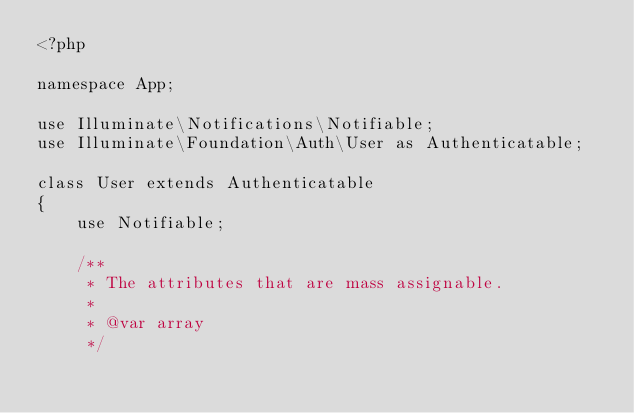<code> <loc_0><loc_0><loc_500><loc_500><_PHP_><?php

namespace App;

use Illuminate\Notifications\Notifiable;
use Illuminate\Foundation\Auth\User as Authenticatable;

class User extends Authenticatable
{
    use Notifiable;

    /**
     * The attributes that are mass assignable.
     *
     * @var array
     */</code> 